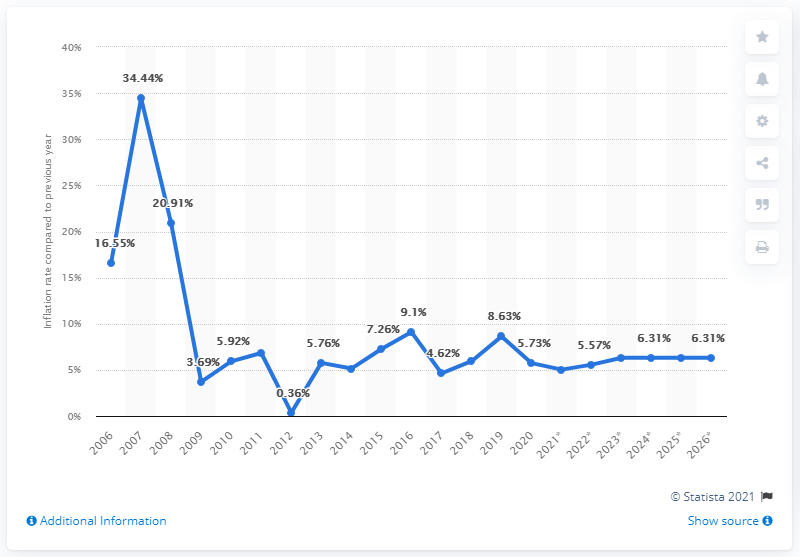Mention a couple of crucial points in this snapshot. The central bankers of Myanmar would prefer 5.94. In 2017, the inflation rate in Burma was 4.62%. In 2016, the expected steady state of inflation in Burma was 5.94. 